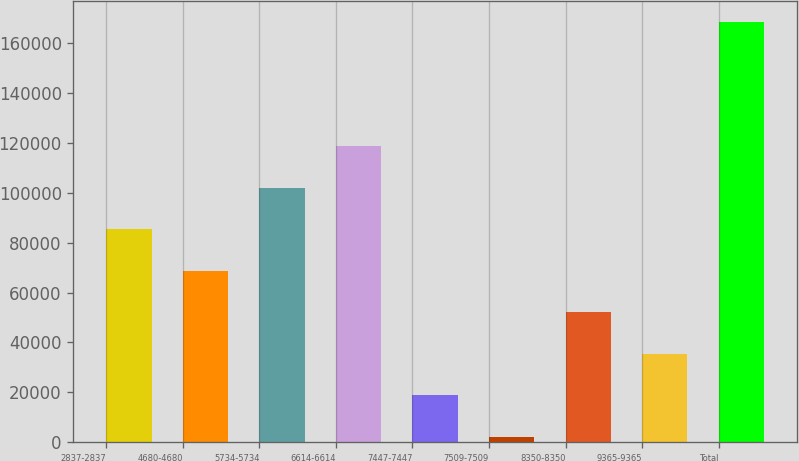Convert chart to OTSL. <chart><loc_0><loc_0><loc_500><loc_500><bar_chart><fcel>2837-2837<fcel>4680-4680<fcel>5734-5734<fcel>6614-6614<fcel>7447-7447<fcel>7509-7509<fcel>8350-8350<fcel>9365-9365<fcel>Total<nl><fcel>85318.5<fcel>68704.8<fcel>101932<fcel>118546<fcel>18863.7<fcel>2250<fcel>52091.1<fcel>35477.4<fcel>168387<nl></chart> 